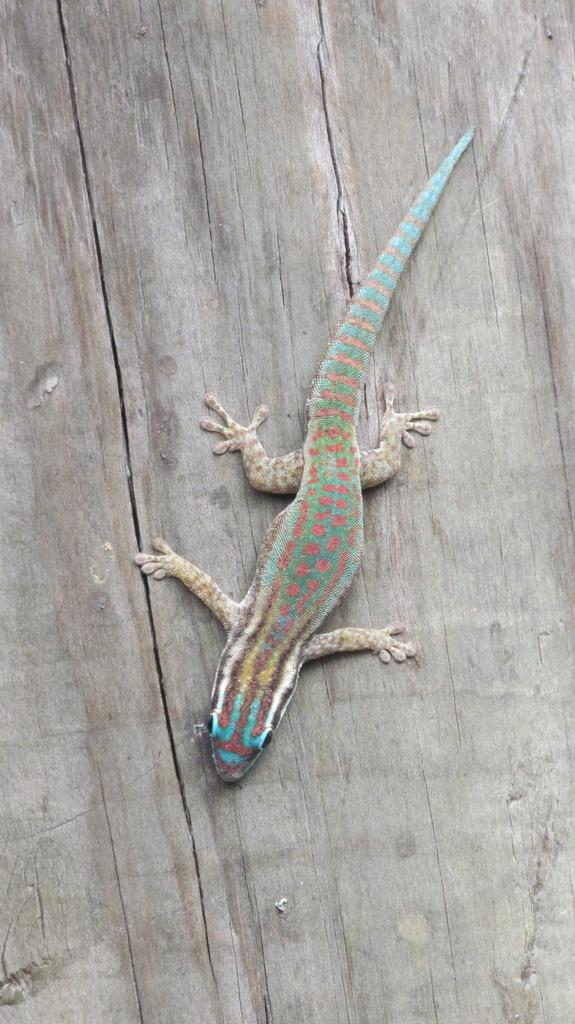What is the main subject in the center of the image? There is a lizard in the center of the image. What type of material is the wall in the background made of? There is a wooden wall in the background of the image. What type of jar is the lizard using to exercise its muscles in the image? There is no jar or any indication of muscle exercise in the image; it simply features a lizard in the center and a wooden wall in the background. 